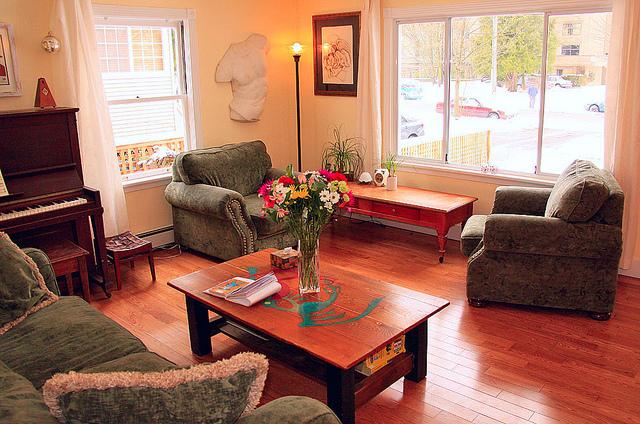How many cars are there?
Write a very short answer. 5. Are the floors tiled?
Short answer required. No. What is in the center of the table?
Keep it brief. Flowers. 